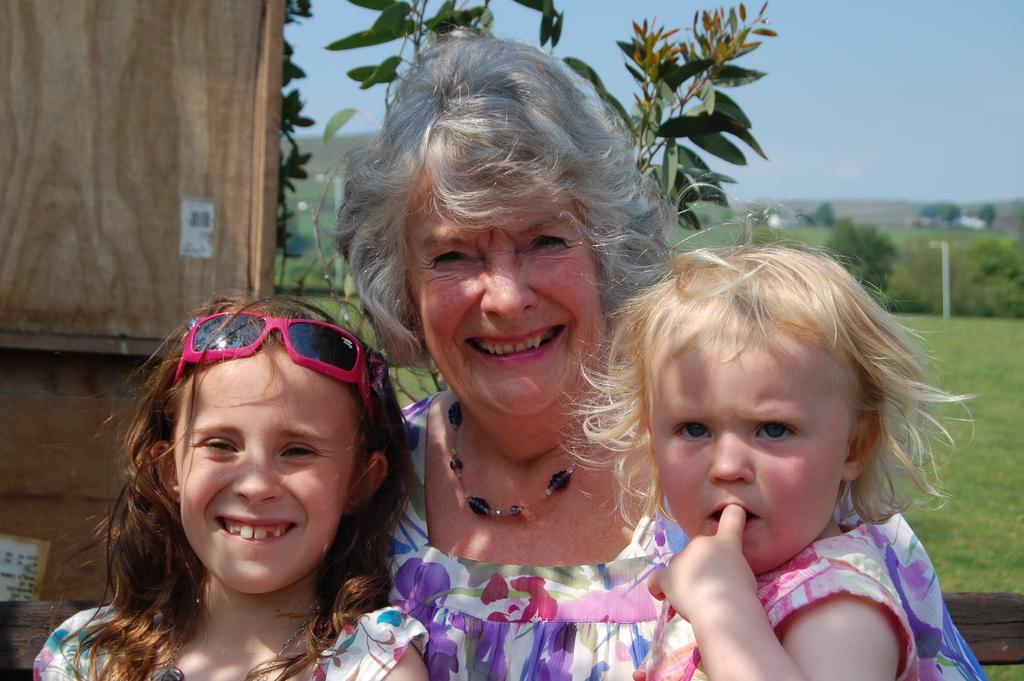In one or two sentences, can you explain what this image depicts? In this picture I can see a woman and couple of girls and I can see smile on their faces and I can see trees and grass on the ground and I can see a blue sky and looks like a wooden wall in the back. 